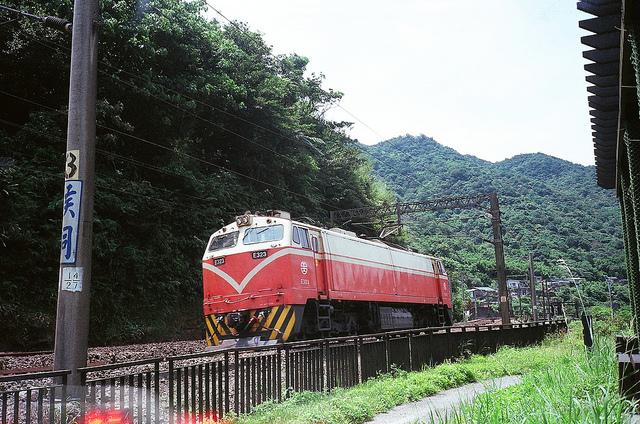What asian country is this?
Quick response, please. China. What is on the left side of the train?
Give a very brief answer. Trees. What number is on the pole?
Answer briefly. 3. How many trains are there?
Keep it brief. 1. 